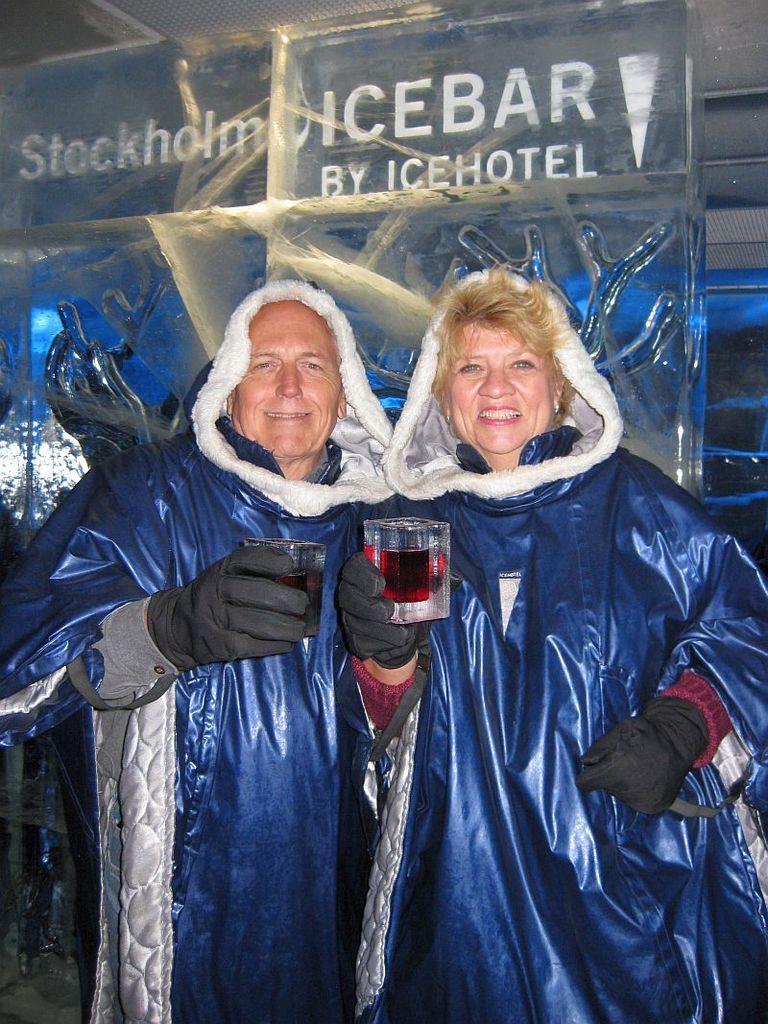Where is this ice bar located?
Give a very brief answer. Stockholm. Who is hosting the icebar?
Your answer should be compact. Icehotel. 